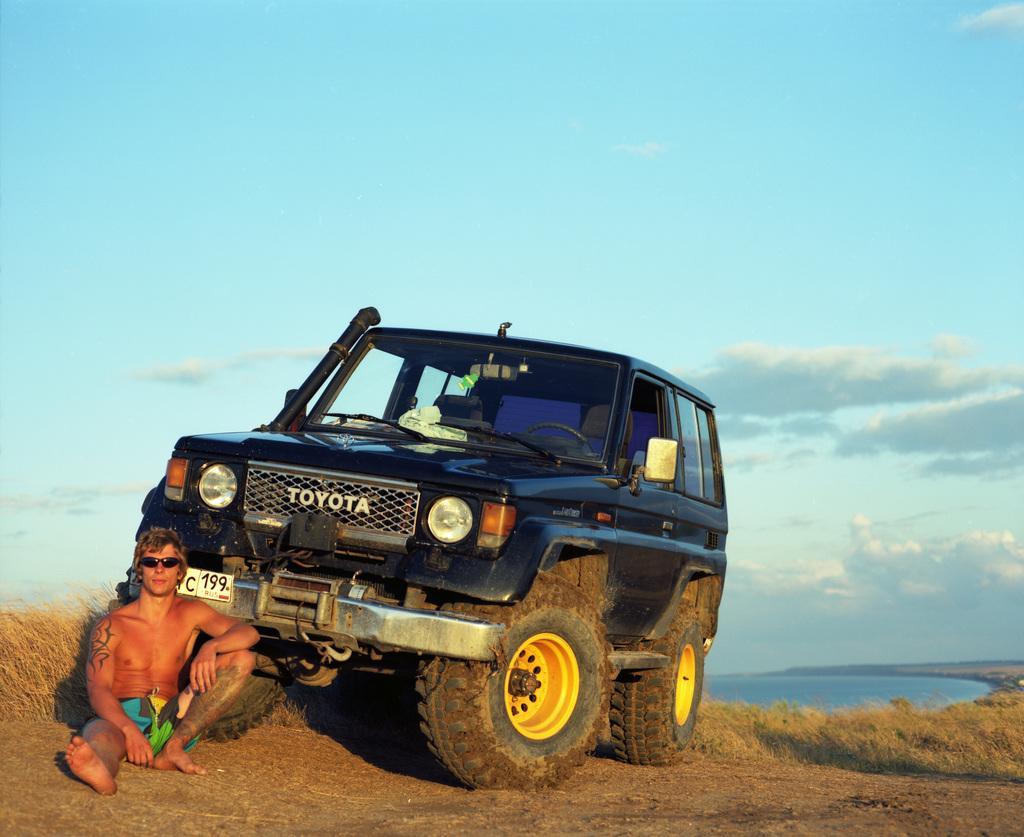Describe this image in one or two sentences. In the picture I can see a man is sitting on the ground. I can also see a black color car and the grass. In the background I can see the sky and the water. 